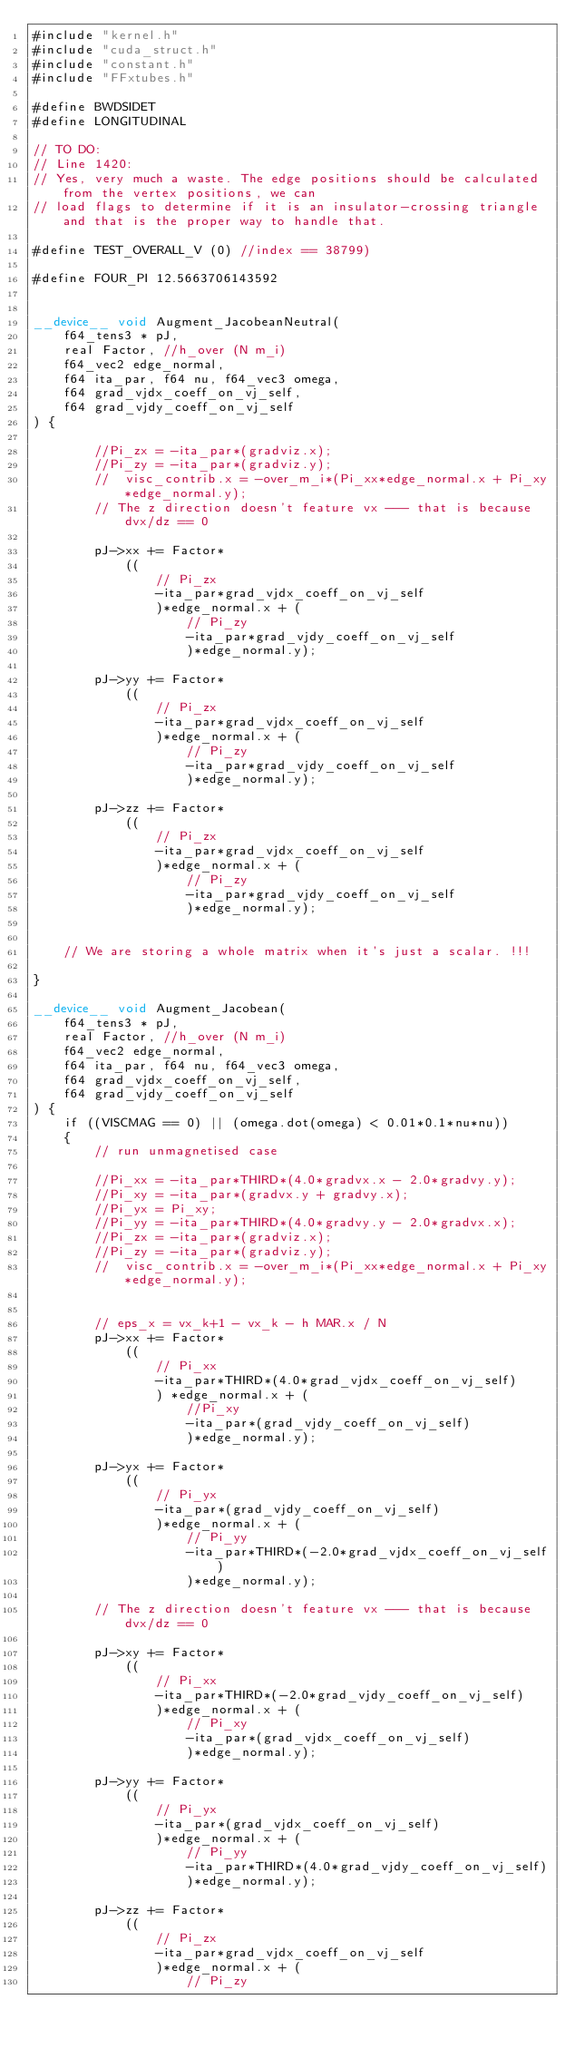Convert code to text. <code><loc_0><loc_0><loc_500><loc_500><_Cuda_>#include "kernel.h"
#include "cuda_struct.h"
#include "constant.h"
#include "FFxtubes.h"

#define BWDSIDET
#define LONGITUDINAL

// TO DO:
// Line 1420:
// Yes, very much a waste. The edge positions should be calculated from the vertex positions, we can
// load flags to determine if it is an insulator-crossing triangle and that is the proper way to handle that.

#define TEST_OVERALL_V (0) //index == 38799)

#define FOUR_PI 12.5663706143592


__device__ void Augment_JacobeanNeutral(
	f64_tens3 * pJ,
	real Factor, //h_over (N m_i)
	f64_vec2 edge_normal,
	f64 ita_par, f64 nu, f64_vec3 omega,
	f64 grad_vjdx_coeff_on_vj_self,
	f64 grad_vjdy_coeff_on_vj_self
) {
	
		//Pi_zx = -ita_par*(gradviz.x);
		//Pi_zy = -ita_par*(gradviz.y);		
		//	visc_contrib.x = -over_m_i*(Pi_xx*edge_normal.x + Pi_xy*edge_normal.y);
		// The z direction doesn't feature vx --- that is because dvx/dz == 0

		pJ->xx += Factor*
			((
				// Pi_zx
				-ita_par*grad_vjdx_coeff_on_vj_self
				)*edge_normal.x + (
					// Pi_zy
					-ita_par*grad_vjdy_coeff_on_vj_self
					)*edge_normal.y);
		
		pJ->yy += Factor*
			((
				// Pi_zx
				-ita_par*grad_vjdx_coeff_on_vj_self
				)*edge_normal.x + (
					// Pi_zy
					-ita_par*grad_vjdy_coeff_on_vj_self
					)*edge_normal.y);

		pJ->zz += Factor*
			((
				// Pi_zx
				-ita_par*grad_vjdx_coeff_on_vj_self
				)*edge_normal.x + (
					// Pi_zy
					-ita_par*grad_vjdy_coeff_on_vj_self
					)*edge_normal.y);	


	// We are storing a whole matrix when it's just a scalar. !!!

}

__device__ void Augment_Jacobean(
	f64_tens3 * pJ, 
	real Factor, //h_over (N m_i)
	f64_vec2 edge_normal, 
	f64 ita_par, f64 nu, f64_vec3 omega,
	f64 grad_vjdx_coeff_on_vj_self,
	f64 grad_vjdy_coeff_on_vj_self
) {
	if ((VISCMAG == 0) || (omega.dot(omega) < 0.01*0.1*nu*nu))
	{
		// run unmagnetised case

		//Pi_xx = -ita_par*THIRD*(4.0*gradvx.x - 2.0*gradvy.y);
		//Pi_xy = -ita_par*(gradvx.y + gradvy.x);
		//Pi_yx = Pi_xy;
		//Pi_yy = -ita_par*THIRD*(4.0*gradvy.y - 2.0*gradvx.x);
		//Pi_zx = -ita_par*(gradviz.x);
		//Pi_zy = -ita_par*(gradviz.y);		
		//	visc_contrib.x = -over_m_i*(Pi_xx*edge_normal.x + Pi_xy*edge_normal.y);


		// eps_x = vx_k+1 - vx_k - h MAR.x / N
		pJ->xx += Factor*
			((
				// Pi_xx
				-ita_par*THIRD*(4.0*grad_vjdx_coeff_on_vj_self)
				) *edge_normal.x + (
					//Pi_xy
					-ita_par*(grad_vjdy_coeff_on_vj_self)
					)*edge_normal.y);

		pJ->yx += Factor*
			((
				// Pi_yx
				-ita_par*(grad_vjdy_coeff_on_vj_self)
				)*edge_normal.x + (
					// Pi_yy
					-ita_par*THIRD*(-2.0*grad_vjdx_coeff_on_vj_self)
					)*edge_normal.y);

		// The z direction doesn't feature vx --- that is because dvx/dz == 0

		pJ->xy += Factor*
			((
				// Pi_xx
				-ita_par*THIRD*(-2.0*grad_vjdy_coeff_on_vj_self)
				)*edge_normal.x + (
					// Pi_xy
					-ita_par*(grad_vjdx_coeff_on_vj_self)
					)*edge_normal.y);

		pJ->yy += Factor*
			((
				// Pi_yx
				-ita_par*(grad_vjdx_coeff_on_vj_self)
				)*edge_normal.x + (
					// Pi_yy
					-ita_par*THIRD*(4.0*grad_vjdy_coeff_on_vj_self)
					)*edge_normal.y);

		pJ->zz += Factor*
			((
				// Pi_zx
				-ita_par*grad_vjdx_coeff_on_vj_self
				)*edge_normal.x + (
					// Pi_zy</code> 